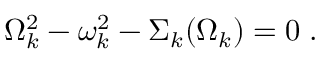Convert formula to latex. <formula><loc_0><loc_0><loc_500><loc_500>\Omega _ { k } ^ { 2 } - \omega _ { k } ^ { 2 } - \Sigma _ { k } ( \Omega _ { k } ) = 0 \, .</formula> 